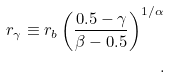<formula> <loc_0><loc_0><loc_500><loc_500>r _ { \gamma } \equiv r _ { b } \left ( \frac { 0 . 5 - \gamma } { \beta - 0 . 5 } \right ) ^ { 1 / \alpha } \\ .</formula> 